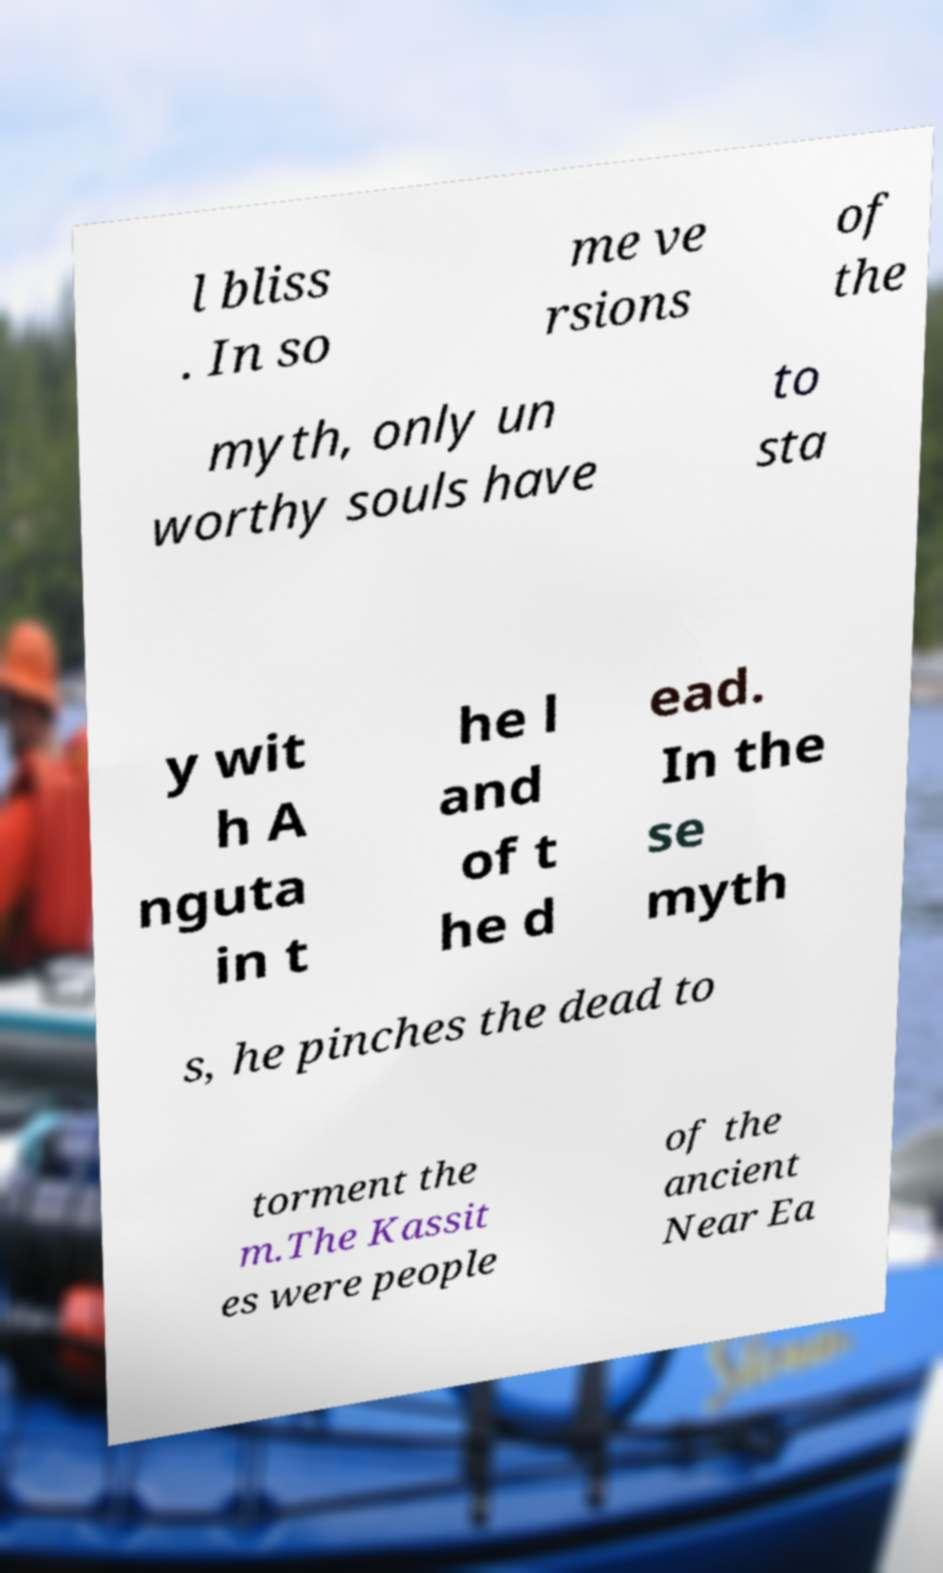For documentation purposes, I need the text within this image transcribed. Could you provide that? l bliss . In so me ve rsions of the myth, only un worthy souls have to sta y wit h A nguta in t he l and of t he d ead. In the se myth s, he pinches the dead to torment the m.The Kassit es were people of the ancient Near Ea 